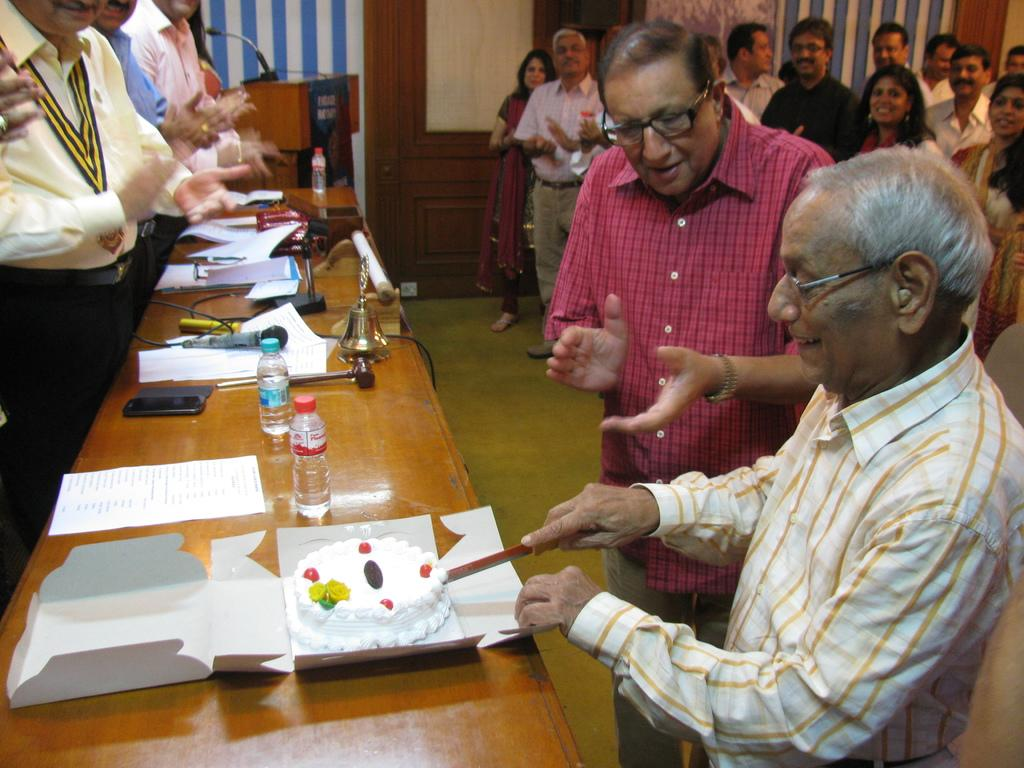What is the man on the right side of the image doing? The man is cutting a cake. Where is the cake located in the image? The cake is on a wooden table. What can be observed about the people in the background of the image? There are people in the background of the image, and they are standing and smiling. What type of bone can be seen sticking out of the man's nose in the image? There is no bone or any such object visible in the man's nose in the image. 